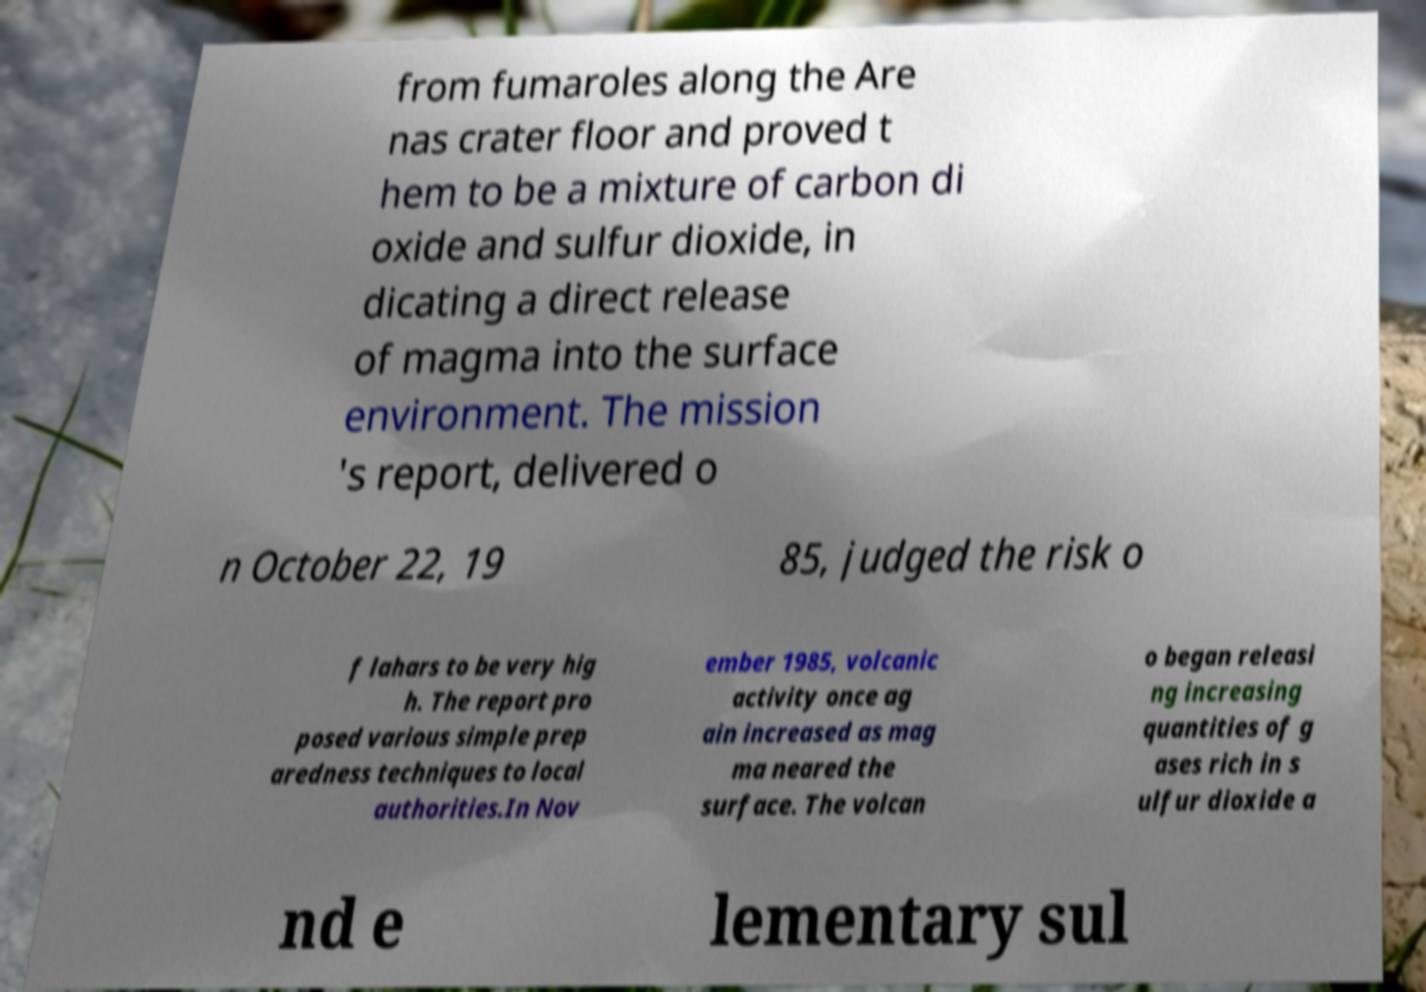There's text embedded in this image that I need extracted. Can you transcribe it verbatim? from fumaroles along the Are nas crater floor and proved t hem to be a mixture of carbon di oxide and sulfur dioxide, in dicating a direct release of magma into the surface environment. The mission 's report, delivered o n October 22, 19 85, judged the risk o f lahars to be very hig h. The report pro posed various simple prep aredness techniques to local authorities.In Nov ember 1985, volcanic activity once ag ain increased as mag ma neared the surface. The volcan o began releasi ng increasing quantities of g ases rich in s ulfur dioxide a nd e lementary sul 